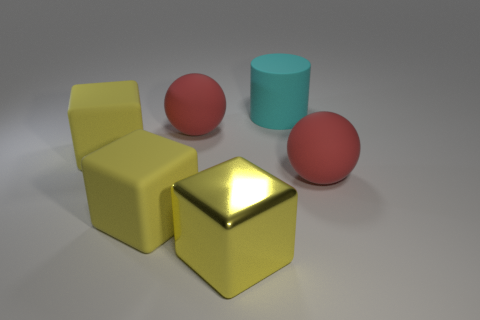Subtract all yellow rubber cubes. How many cubes are left? 1 Add 1 tiny brown rubber objects. How many objects exist? 7 Subtract all cylinders. How many objects are left? 5 Subtract 2 spheres. How many spheres are left? 0 Subtract 0 cyan cubes. How many objects are left? 6 Subtract all green balls. Subtract all yellow blocks. How many balls are left? 2 Subtract all big red rubber balls. Subtract all metal objects. How many objects are left? 3 Add 6 yellow rubber things. How many yellow rubber things are left? 8 Add 2 big red rubber cylinders. How many big red rubber cylinders exist? 2 